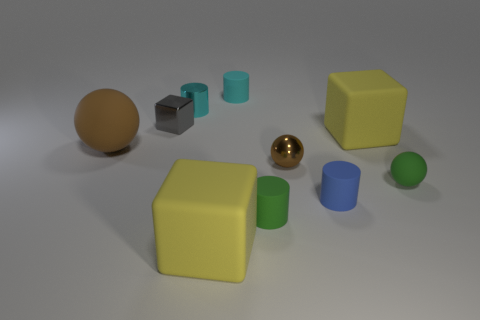Is the shape of the tiny cyan matte object the same as the tiny metal thing in front of the gray thing?
Your response must be concise. No. There is a matte cube in front of the small metal thing in front of the matte ball on the left side of the small cyan matte cylinder; what color is it?
Ensure brevity in your answer.  Yellow. There is a tiny thing in front of the blue thing; is its shape the same as the cyan rubber thing?
Give a very brief answer. Yes. What material is the tiny gray block?
Offer a terse response. Metal. What is the shape of the small matte object right of the yellow block to the right of the yellow matte object that is in front of the tiny green ball?
Ensure brevity in your answer.  Sphere. How many other things are there of the same shape as the tiny gray object?
Your answer should be very brief. 2. There is a shiny ball; does it have the same color as the large rubber object on the left side of the cyan shiny object?
Provide a short and direct response. Yes. What number of large yellow matte objects are there?
Your answer should be very brief. 2. What number of objects are large yellow cubes or tiny metal things?
Offer a terse response. 5. What is the size of the rubber sphere that is the same color as the metallic sphere?
Provide a short and direct response. Large. 